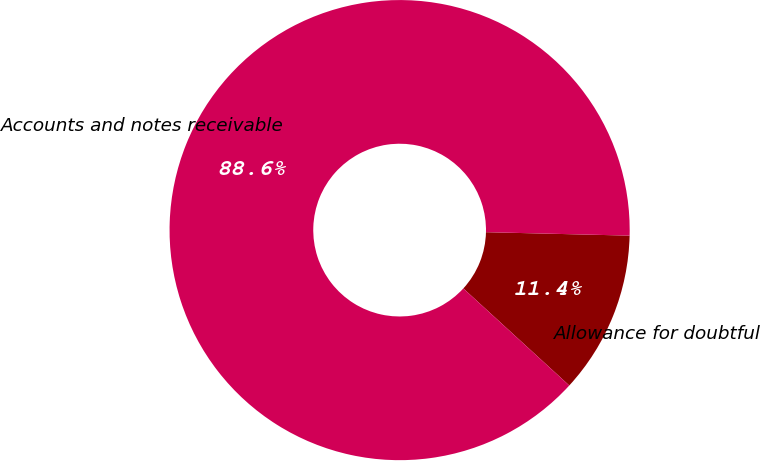<chart> <loc_0><loc_0><loc_500><loc_500><pie_chart><fcel>Allowance for doubtful<fcel>Accounts and notes receivable<nl><fcel>11.42%<fcel>88.58%<nl></chart> 